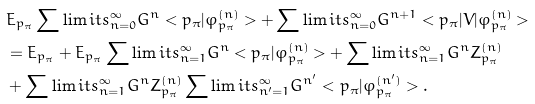<formula> <loc_0><loc_0><loc_500><loc_500>& E _ { p _ { \pi } } \sum \lim i t s _ { n = 0 } ^ { \infty } G ^ { n } < p _ { \pi } | \varphi _ { p _ { \pi } } ^ { ( n ) } > + \sum \lim i t s _ { n = 0 } ^ { \infty } G ^ { n + 1 } < p _ { \pi } | V | \varphi _ { p _ { \pi } } ^ { ( n ) } > \\ & = E _ { p _ { \pi } } + E _ { p _ { \pi } } \sum \lim i t s _ { n = 1 } ^ { \infty } G ^ { n } < p _ { \pi } | \varphi _ { p _ { \pi } } ^ { ( n ) } > + \sum \lim i t s _ { n = 1 } ^ { \infty } G ^ { n } Z _ { p _ { \pi } } ^ { ( n ) } \\ & + \sum \lim i t s _ { n = 1 } ^ { \infty } G ^ { n } Z _ { p _ { \pi } } ^ { ( n ) } \sum \lim i t s _ { n ^ { \prime } = 1 } ^ { \infty } G ^ { n ^ { \prime } } < p _ { \pi } | \varphi _ { p _ { \pi } } ^ { ( n ^ { \prime } ) } > .</formula> 